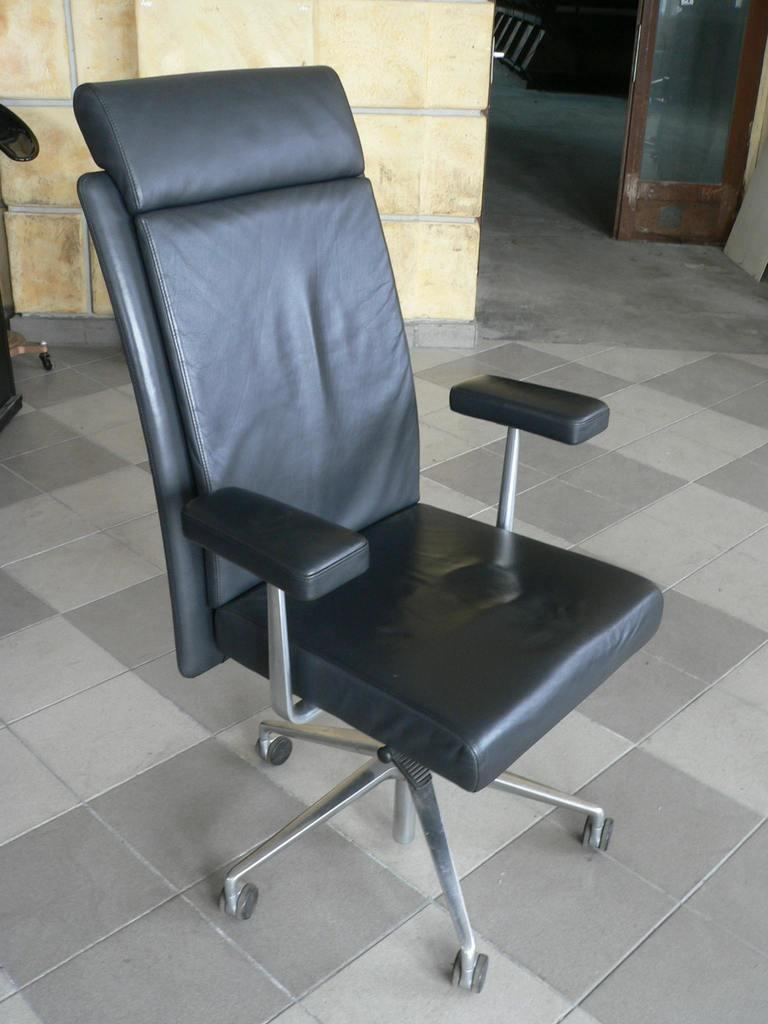How many chairs can be seen in the image? There are two chairs in the image, one in the middle and one at the bottom. What is the background of the image? There is a wall in the image, which serves as the background. What is the surface on which the chairs are placed? There is a floor in the image, on which the chairs are placed. What type of object made of glass is present in the image? There is a glass object in the image, but its specific purpose or shape is not mentioned. Can you see any dirt on the floor in the image? There is no mention of dirt in the image, so we cannot determine if it is present or not. How many times does the person in the image kick the chair? There is no person present in the image, so we cannot determine if any kicking has occurred. 